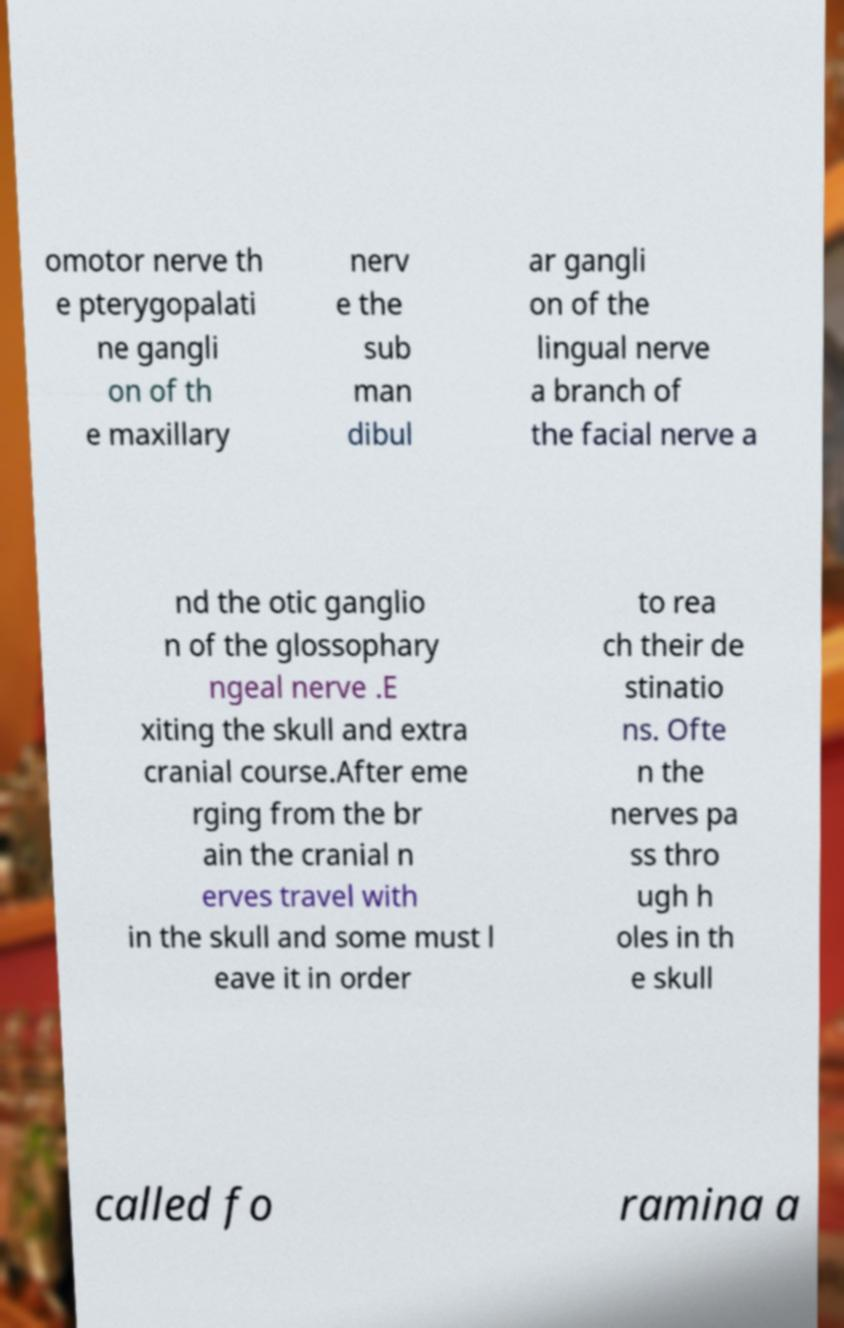Can you read and provide the text displayed in the image?This photo seems to have some interesting text. Can you extract and type it out for me? omotor nerve th e pterygopalati ne gangli on of th e maxillary nerv e the sub man dibul ar gangli on of the lingual nerve a branch of the facial nerve a nd the otic ganglio n of the glossophary ngeal nerve .E xiting the skull and extra cranial course.After eme rging from the br ain the cranial n erves travel with in the skull and some must l eave it in order to rea ch their de stinatio ns. Ofte n the nerves pa ss thro ugh h oles in th e skull called fo ramina a 